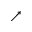<formula> <loc_0><loc_0><loc_500><loc_500>\nearrow</formula> 